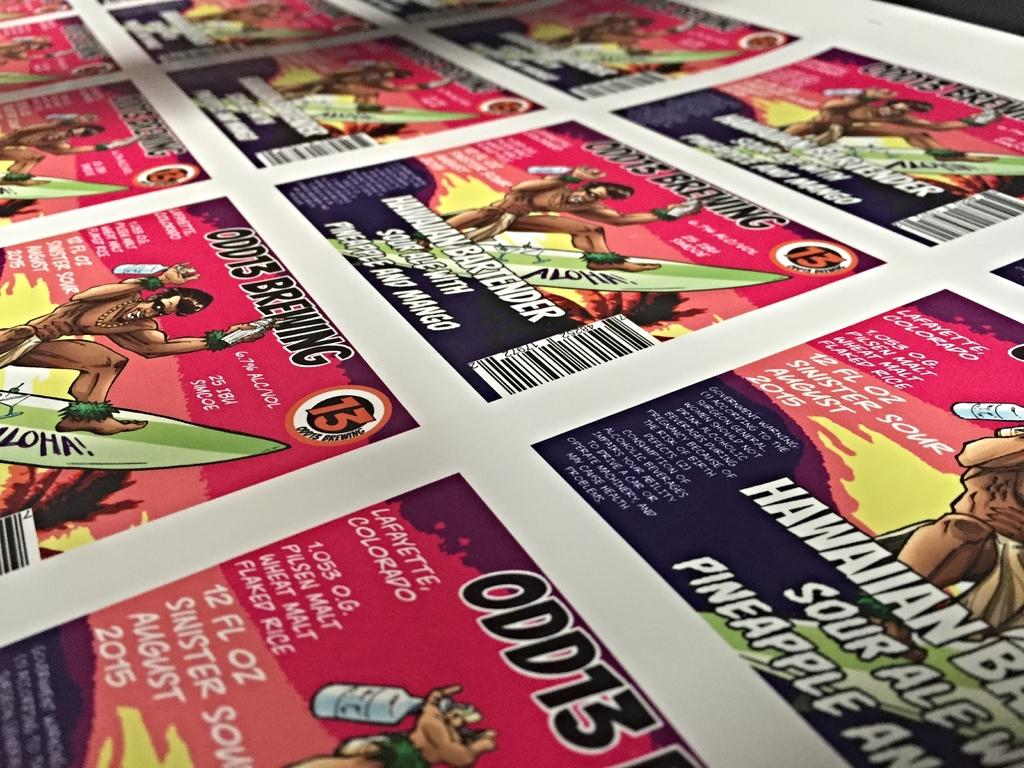What is present in the image that contains both pictures and text? There is a poster in the image that contains both pictures and text. Where is the pocket located in the image? There is no pocket present in the image. What type of road can be seen in the image? There is no road present in the image. 